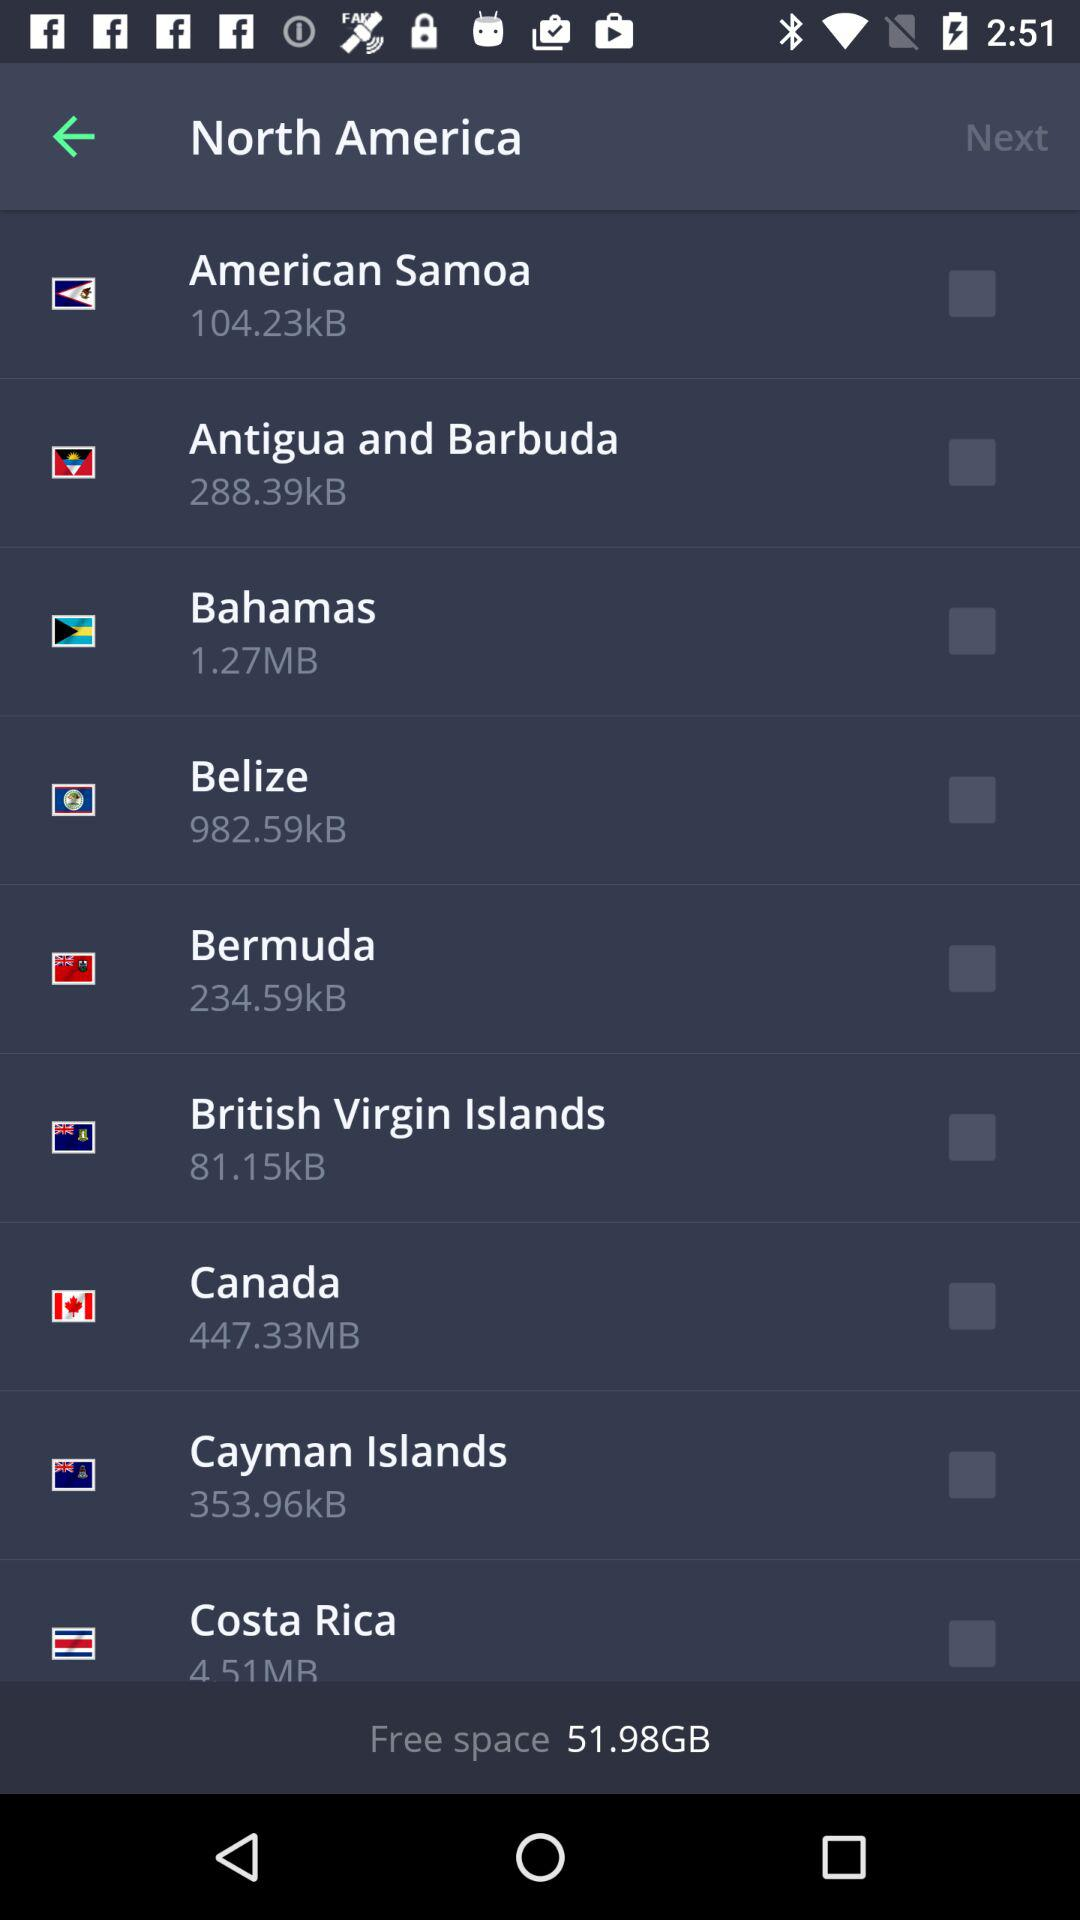What is the current status of "Bahamas"? The current status is "off". 